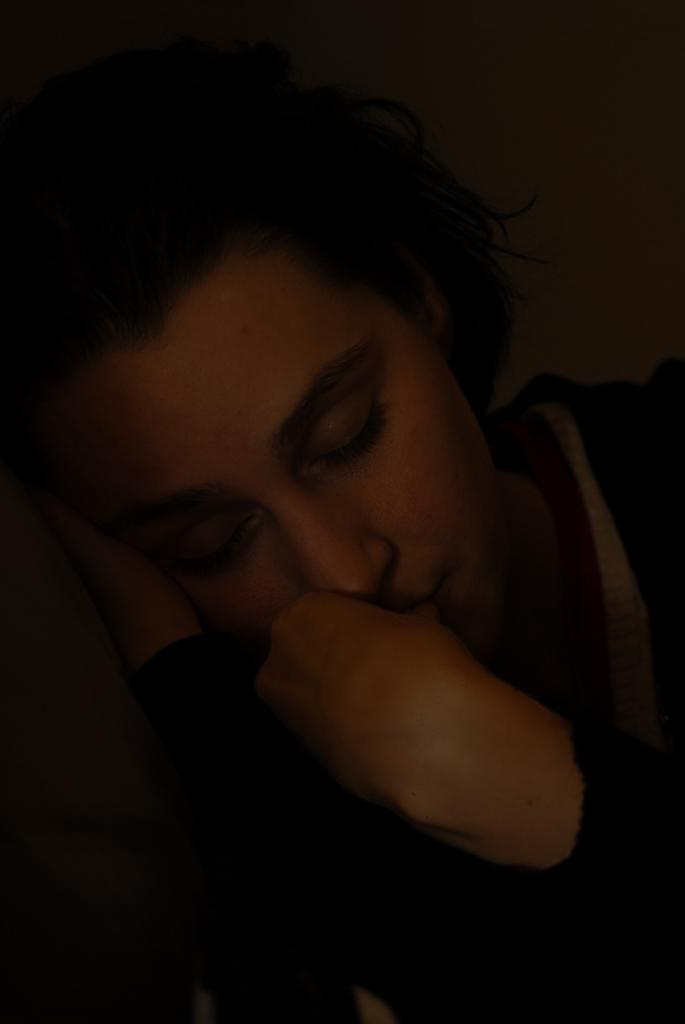What is the main subject of the image? There is a person sleeping in the image. Can you describe the lighting in the image? The top and bottom of the image have a dark view. What type of bottle is being used in the process depicted in the image? There is no process or bottle present in the image; it only shows a person sleeping. Is there a fire visible in the image? No, there is no fire visible in the image. 